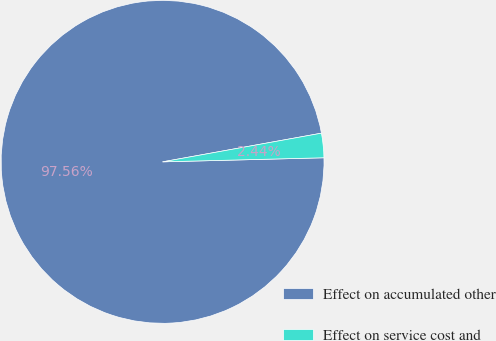Convert chart to OTSL. <chart><loc_0><loc_0><loc_500><loc_500><pie_chart><fcel>Effect on accumulated other<fcel>Effect on service cost and<nl><fcel>97.56%<fcel>2.44%<nl></chart> 